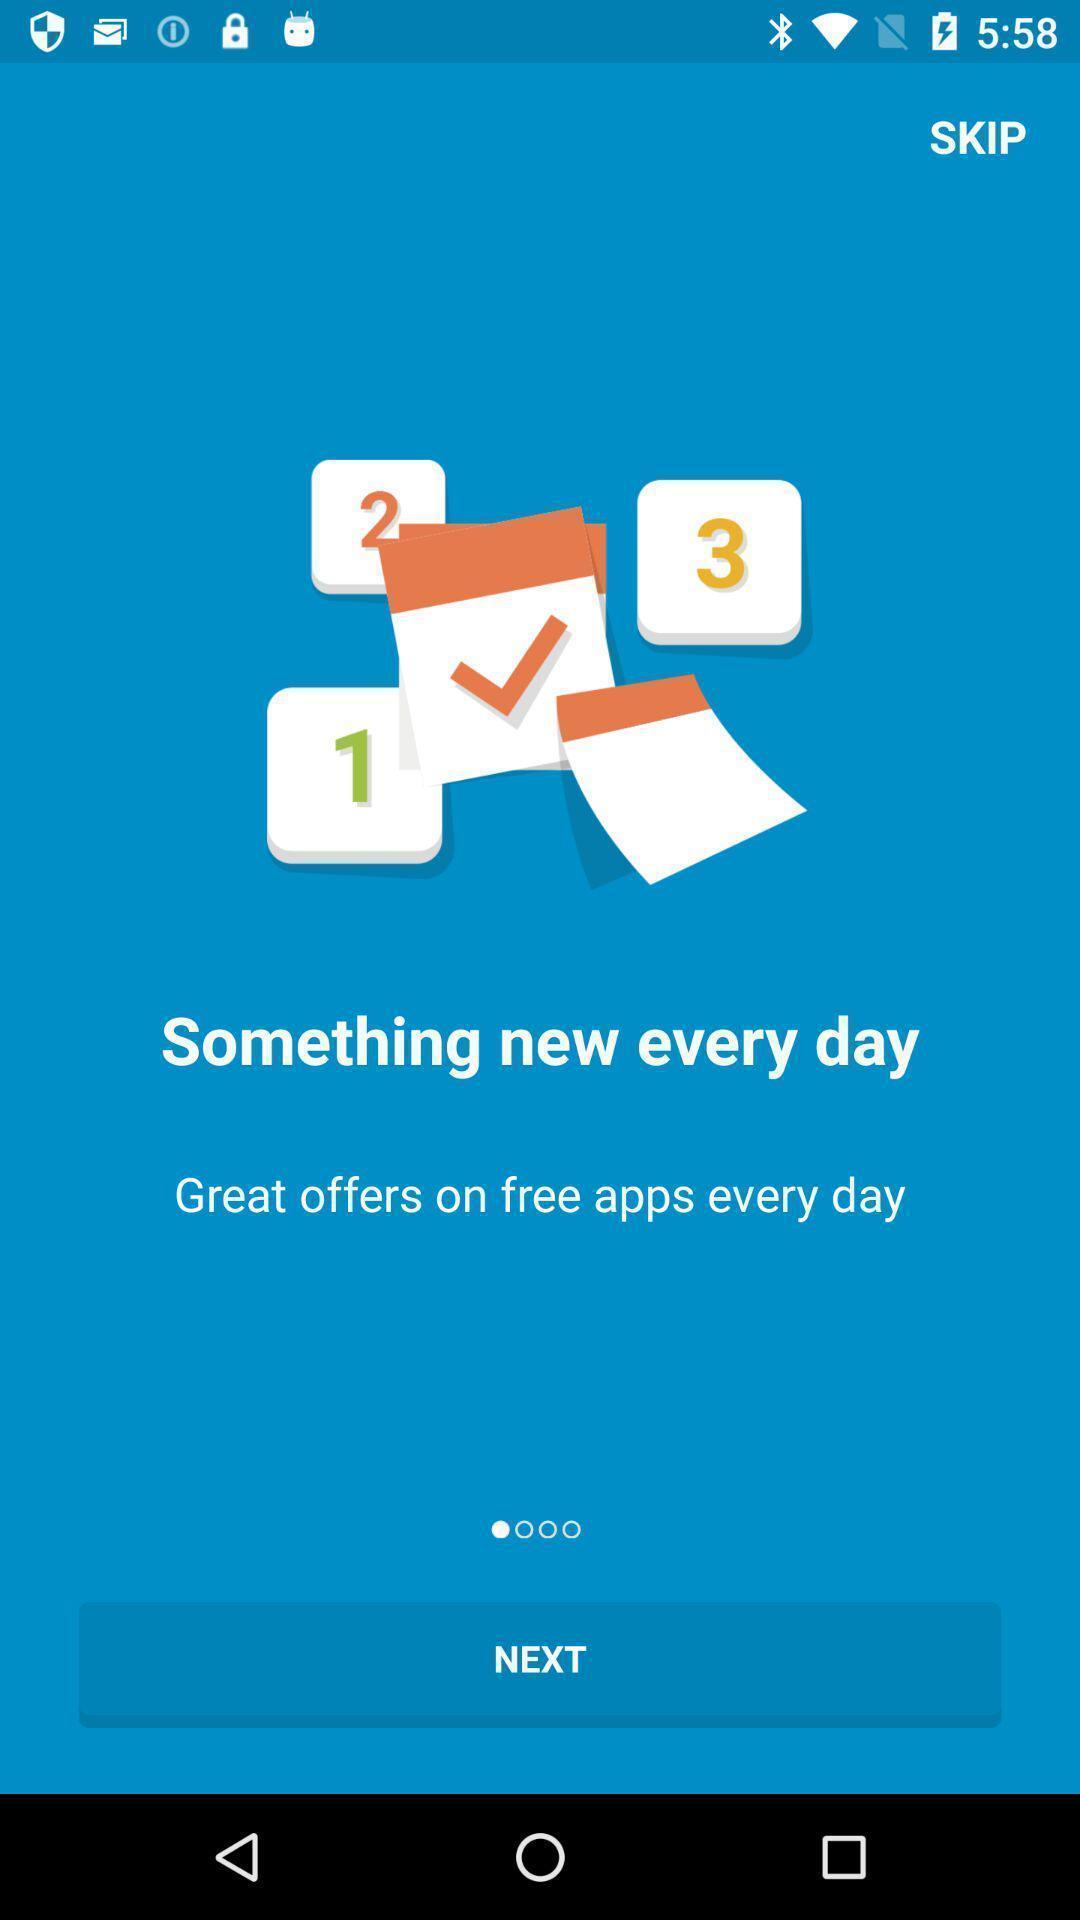Provide a textual representation of this image. Welcome page with next option. 